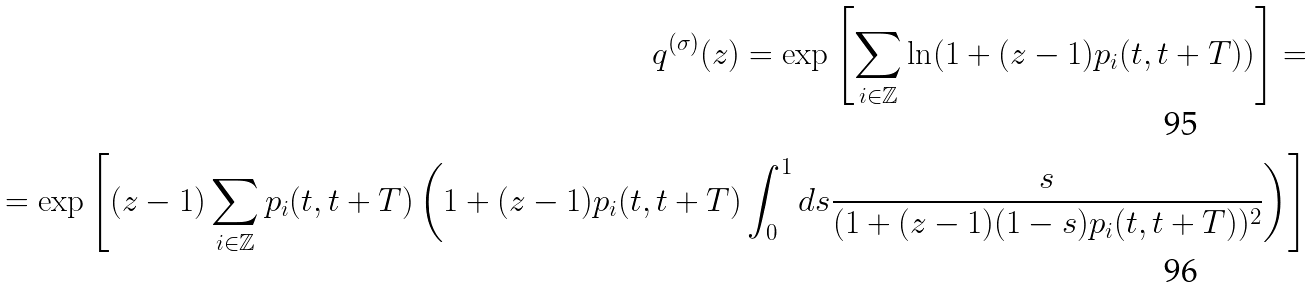Convert formula to latex. <formula><loc_0><loc_0><loc_500><loc_500>q ^ { ( \sigma ) } ( z ) = \exp \left [ \sum _ { i \in \mathbb { Z } } \ln ( 1 + ( z - 1 ) p _ { i } ( t , t + T ) ) \right ] = \\ = \exp \left [ ( z - 1 ) \sum _ { i \in \mathbb { Z } } p _ { i } ( t , t + T ) \left ( 1 + ( z - 1 ) p _ { i } ( t , t + T ) \int _ { 0 } ^ { 1 } d s \frac { s } { ( 1 + ( z - 1 ) ( 1 - s ) p _ { i } ( t , t + T ) ) ^ { 2 } } \right ) \right ]</formula> 